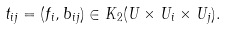Convert formula to latex. <formula><loc_0><loc_0><loc_500><loc_500>t _ { i j } = ( f _ { i } , b _ { i j } ) \in K _ { 2 } ( U \times U _ { i } \times U _ { j } ) .</formula> 